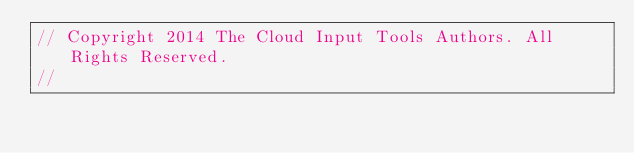<code> <loc_0><loc_0><loc_500><loc_500><_JavaScript_>// Copyright 2014 The Cloud Input Tools Authors. All Rights Reserved.
//</code> 